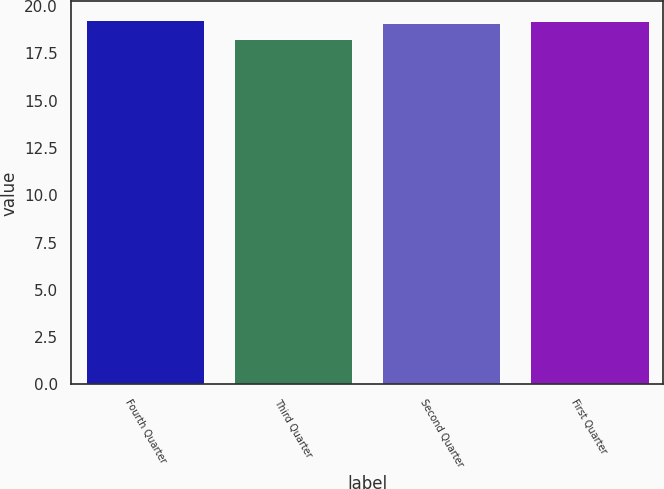<chart> <loc_0><loc_0><loc_500><loc_500><bar_chart><fcel>Fourth Quarter<fcel>Third Quarter<fcel>Second Quarter<fcel>First Quarter<nl><fcel>19.28<fcel>18.27<fcel>19.1<fcel>19.19<nl></chart> 